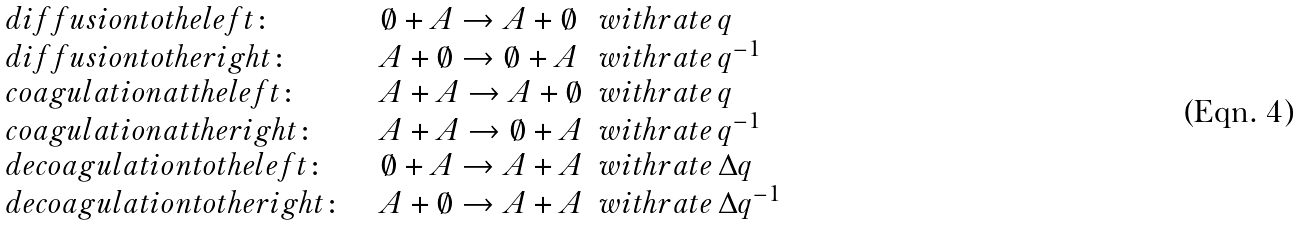<formula> <loc_0><loc_0><loc_500><loc_500>\begin{array} { l l l l } d i f f u s i o n t o t h e l e f t \colon & & \emptyset + A \rightarrow A + \emptyset & w i t h r a t e \, q \\ d i f f u s i o n t o t h e r i g h t \colon & & A + \emptyset \rightarrow \emptyset + A & w i t h r a t e \, q ^ { - 1 } \\ c o a g u l a t i o n a t t h e l e f t \colon & & A + A \rightarrow A + \emptyset & w i t h r a t e \, q \\ c o a g u l a t i o n a t t h e r i g h t \colon & & A + A \rightarrow \emptyset + A & w i t h r a t e \, q ^ { - 1 } \\ d e c o a g u l a t i o n t o t h e l e f t \colon & & \emptyset + A \rightarrow A + A & w i t h r a t e \, \Delta q \\ d e c o a g u l a t i o n t o t h e r i g h t \colon & & A + \emptyset \rightarrow A + A & w i t h r a t e \, \Delta q ^ { - 1 } \end{array}</formula> 